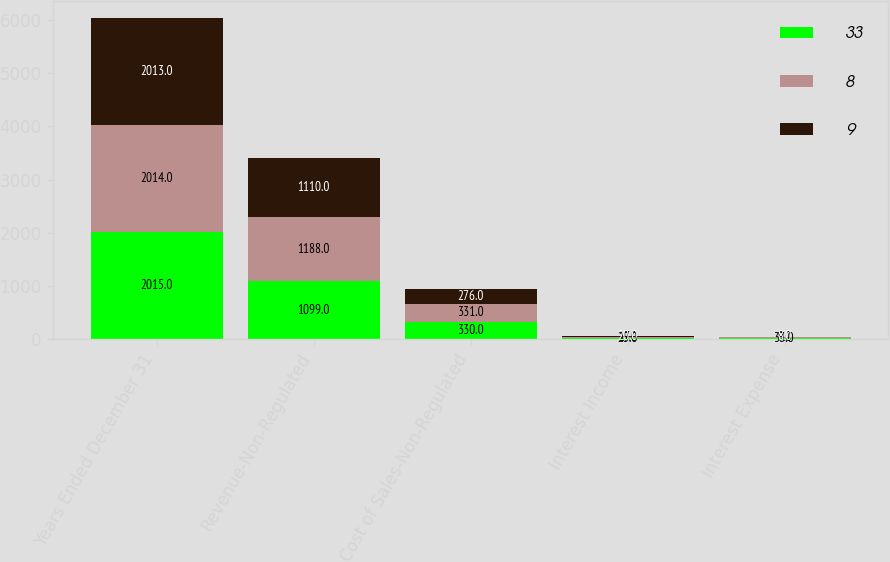<chart> <loc_0><loc_0><loc_500><loc_500><stacked_bar_chart><ecel><fcel>Years Ended December 31<fcel>Revenue-Non-Regulated<fcel>Cost of Sales-Non-Regulated<fcel>Interest Income<fcel>Interest Expense<nl><fcel>33<fcel>2015<fcel>1099<fcel>330<fcel>25<fcel>33<nl><fcel>8<fcel>2014<fcel>1188<fcel>331<fcel>17<fcel>9<nl><fcel>9<fcel>2013<fcel>1110<fcel>276<fcel>20<fcel>8<nl></chart> 